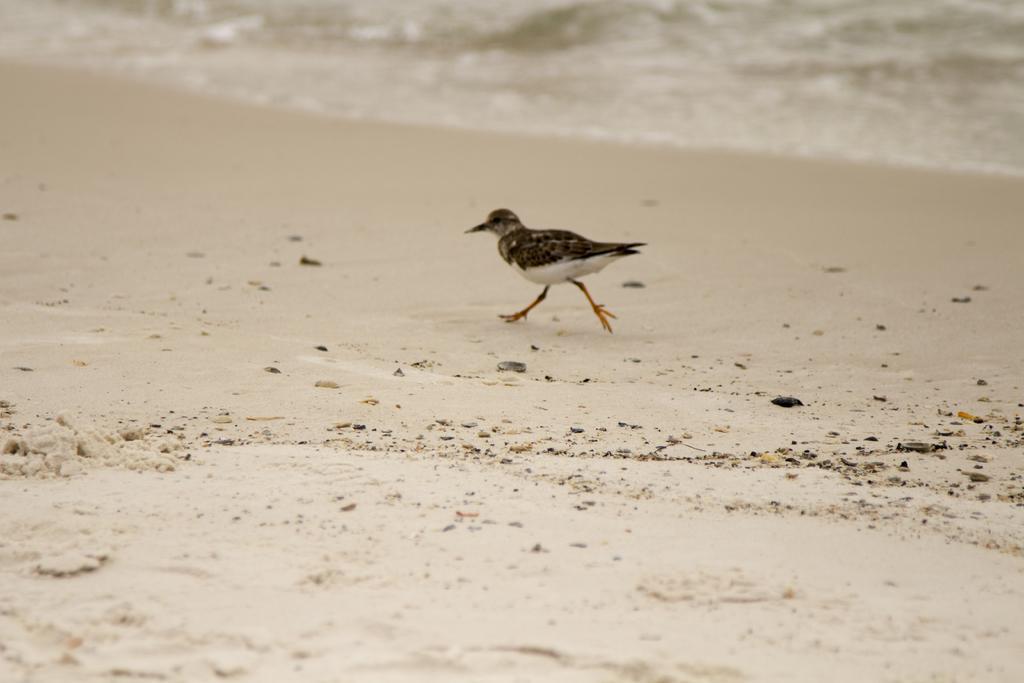Can you describe this image briefly? There is a bird walking on sand and we can see water. 